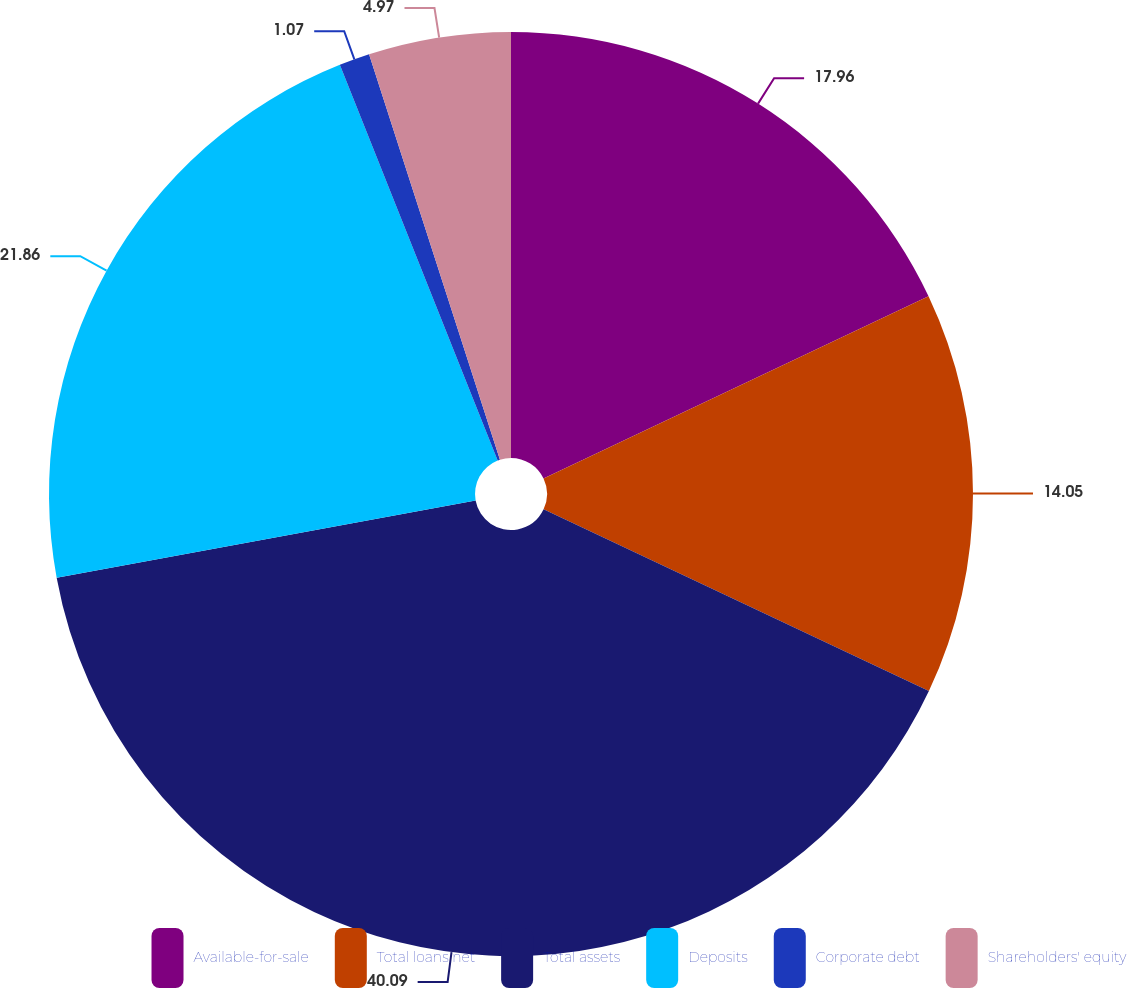<chart> <loc_0><loc_0><loc_500><loc_500><pie_chart><fcel>Available-for-sale<fcel>Total loans net<fcel>Total assets<fcel>Deposits<fcel>Corporate debt<fcel>Shareholders' equity<nl><fcel>17.96%<fcel>14.05%<fcel>40.09%<fcel>21.86%<fcel>1.07%<fcel>4.97%<nl></chart> 